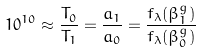<formula> <loc_0><loc_0><loc_500><loc_500>1 0 ^ { 1 0 } \approx \frac { T _ { 0 } } { T _ { 1 } } = \frac { a _ { 1 } } { a _ { 0 } } = \frac { f _ { \lambda } ( \beta ^ { g } _ { 1 } ) } { f _ { \lambda } ( \beta ^ { g } _ { 0 } ) }</formula> 